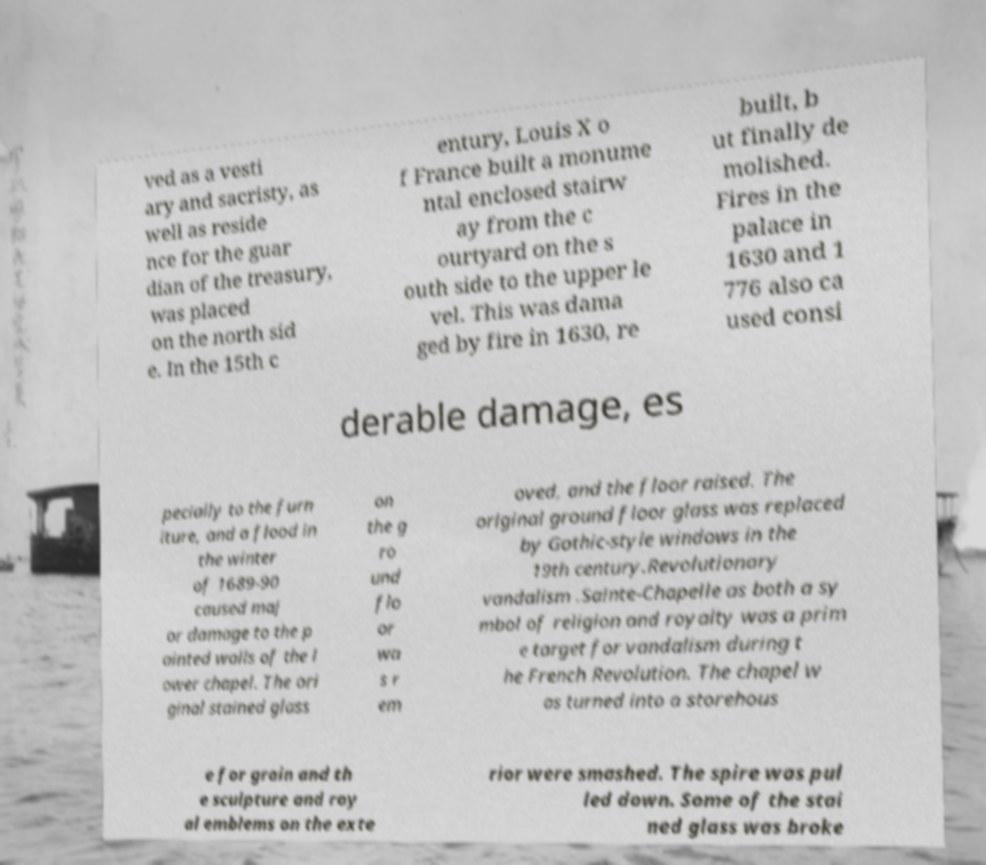I need the written content from this picture converted into text. Can you do that? ved as a vesti ary and sacristy, as well as reside nce for the guar dian of the treasury, was placed on the north sid e. In the 15th c entury, Louis X o f France built a monume ntal enclosed stairw ay from the c ourtyard on the s outh side to the upper le vel. This was dama ged by fire in 1630, re built, b ut finally de molished. Fires in the palace in 1630 and 1 776 also ca used consi derable damage, es pecially to the furn iture, and a flood in the winter of 1689-90 caused maj or damage to the p ainted walls of the l ower chapel. The ori ginal stained glass on the g ro und flo or wa s r em oved, and the floor raised. The original ground floor glass was replaced by Gothic-style windows in the 19th century.Revolutionary vandalism .Sainte-Chapelle as both a sy mbol of religion and royalty was a prim e target for vandalism during t he French Revolution. The chapel w as turned into a storehous e for grain and th e sculpture and roy al emblems on the exte rior were smashed. The spire was pul led down. Some of the stai ned glass was broke 